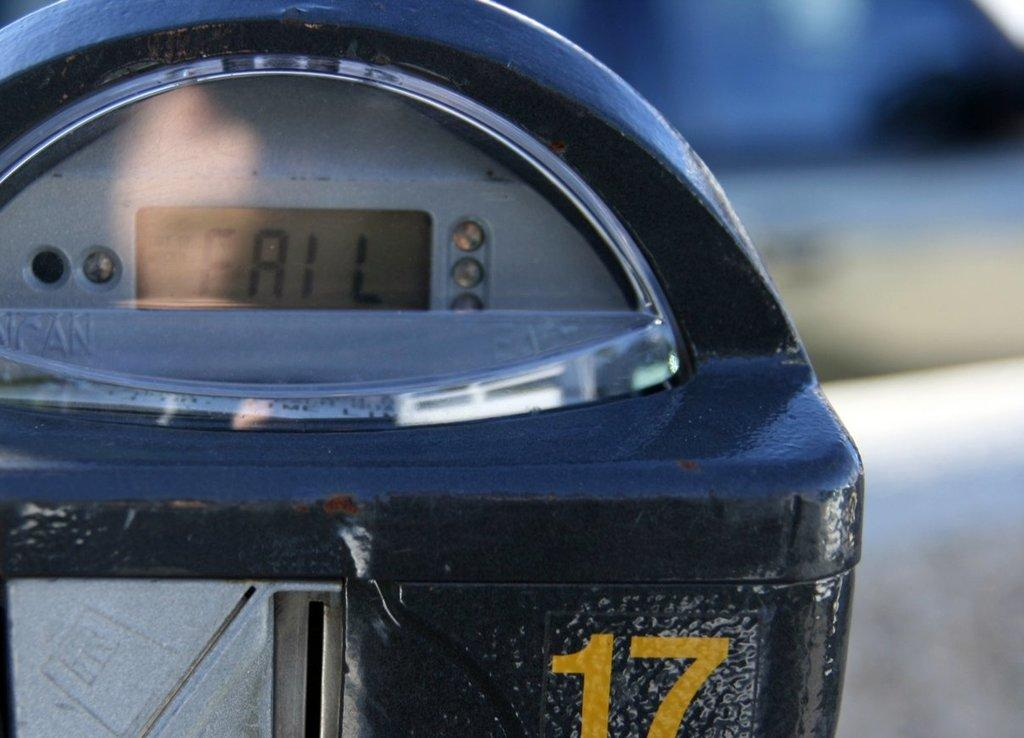<image>
Create a compact narrative representing the image presented. Parking meter # 17 displaying "Fail" on it's screen. 